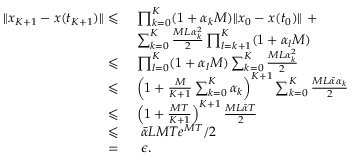Convert formula to latex. <formula><loc_0><loc_0><loc_500><loc_500>\begin{array} { r l } { \| x _ { K + 1 } - x ( t _ { K + 1 } ) \| \leqslant } & { \prod _ { k = 0 } ^ { K } ( 1 + \alpha _ { k } M ) \| x _ { 0 } - x ( t _ { 0 } ) \| + } \\ & { \sum _ { k = 0 } ^ { K } \frac { M L \alpha _ { k } ^ { 2 } } { 2 } \prod _ { l = k + 1 } ^ { K } ( 1 + \alpha _ { l } M ) } \\ { \leqslant } & { \prod _ { l = 0 } ^ { K } ( 1 + \alpha _ { l } M ) \sum _ { k = 0 } ^ { K } \frac { M L \alpha _ { k } ^ { 2 } } { 2 } } \\ { \leqslant } & { \left ( 1 + \frac { M } { K + 1 } \sum _ { k = 0 } ^ { K } \alpha _ { k } \right ) ^ { K + 1 } \sum _ { k = 0 } ^ { K } \frac { M L \bar { \alpha } \alpha _ { k } } { 2 } } \\ { \leqslant } & { \left ( 1 + \frac { M T } { K + 1 } \right ) ^ { K + 1 } \frac { M L \bar { \alpha } T } { 2 } } \\ { \leqslant } & { \bar { \alpha } L M T e ^ { M T } / 2 } \\ { = } & { \epsilon . } \end{array}</formula> 